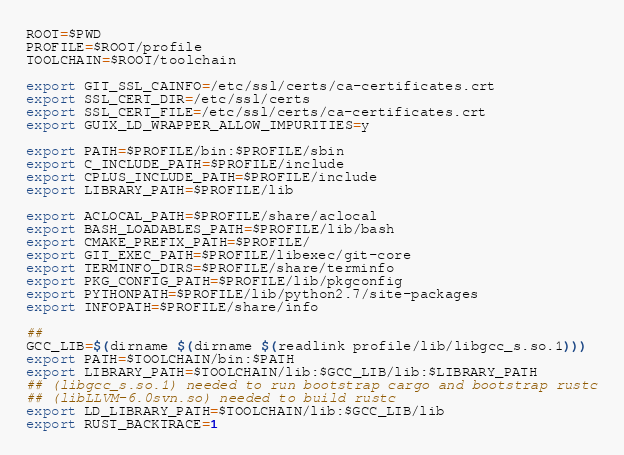<code> <loc_0><loc_0><loc_500><loc_500><_Bash_>ROOT=$PWD
PROFILE=$ROOT/profile
TOOLCHAIN=$ROOT/toolchain

export GIT_SSL_CAINFO=/etc/ssl/certs/ca-certificates.crt
export SSL_CERT_DIR=/etc/ssl/certs
export SSL_CERT_FILE=/etc/ssl/certs/ca-certificates.crt
export GUIX_LD_WRAPPER_ALLOW_IMPURITIES=y

export PATH=$PROFILE/bin:$PROFILE/sbin
export C_INCLUDE_PATH=$PROFILE/include
export CPLUS_INCLUDE_PATH=$PROFILE/include
export LIBRARY_PATH=$PROFILE/lib

export ACLOCAL_PATH=$PROFILE/share/aclocal
export BASH_LOADABLES_PATH=$PROFILE/lib/bash
export CMAKE_PREFIX_PATH=$PROFILE/
export GIT_EXEC_PATH=$PROFILE/libexec/git-core
export TERMINFO_DIRS=$PROFILE/share/terminfo
export PKG_CONFIG_PATH=$PROFILE/lib/pkgconfig
export PYTHONPATH=$PROFILE/lib/python2.7/site-packages
export INFOPATH=$PROFILE/share/info

##
GCC_LIB=$(dirname $(dirname $(readlink profile/lib/libgcc_s.so.1)))
export PATH=$TOOLCHAIN/bin:$PATH
export LIBRARY_PATH=$TOOLCHAIN/lib:$GCC_LIB/lib:$LIBRARY_PATH
## (libgcc_s.so.1) needed to run bootstrap cargo and bootstrap rustc
## (libLLVM-6.0svn.so) needed to build rustc
export LD_LIBRARY_PATH=$TOOLCHAIN/lib:$GCC_LIB/lib
export RUST_BACKTRACE=1
</code> 